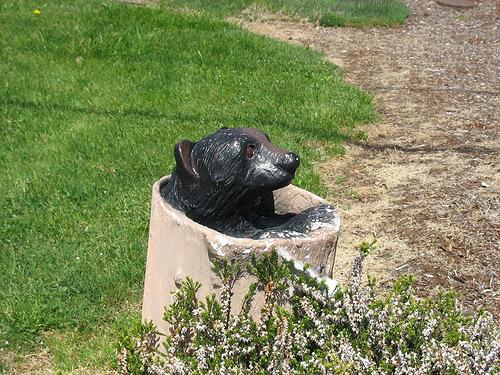Is this a real bear?
Be succinct. No. What animal is shown?
Quick response, please. Bear. What color is the bear?
Write a very short answer. Black. 